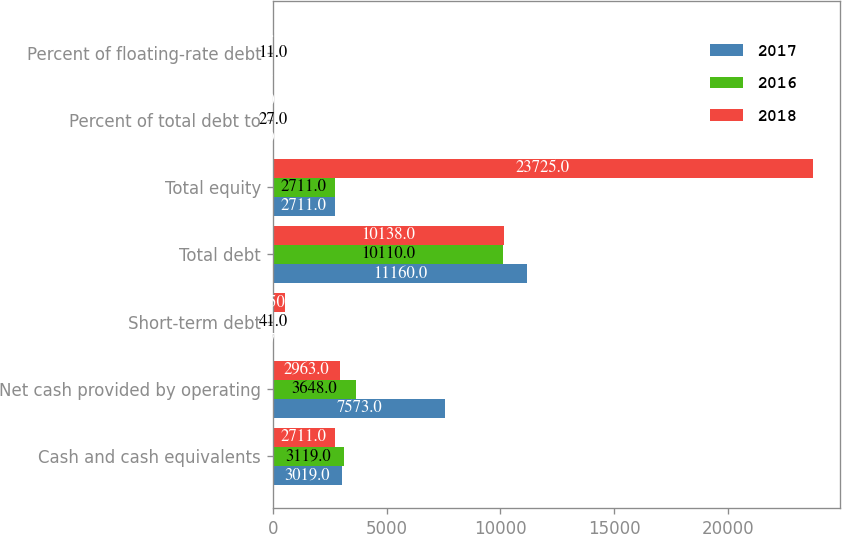<chart> <loc_0><loc_0><loc_500><loc_500><stacked_bar_chart><ecel><fcel>Cash and cash equivalents<fcel>Net cash provided by operating<fcel>Short-term debt<fcel>Total debt<fcel>Total equity<fcel>Percent of total debt to<fcel>Percent of floating-rate debt<nl><fcel>2017<fcel>3019<fcel>7573<fcel>67<fcel>11160<fcel>2711<fcel>29<fcel>11<nl><fcel>2016<fcel>3119<fcel>3648<fcel>41<fcel>10110<fcel>2711<fcel>27<fcel>11<nl><fcel>2018<fcel>2711<fcel>2963<fcel>550<fcel>10138<fcel>23725<fcel>30<fcel>3<nl></chart> 